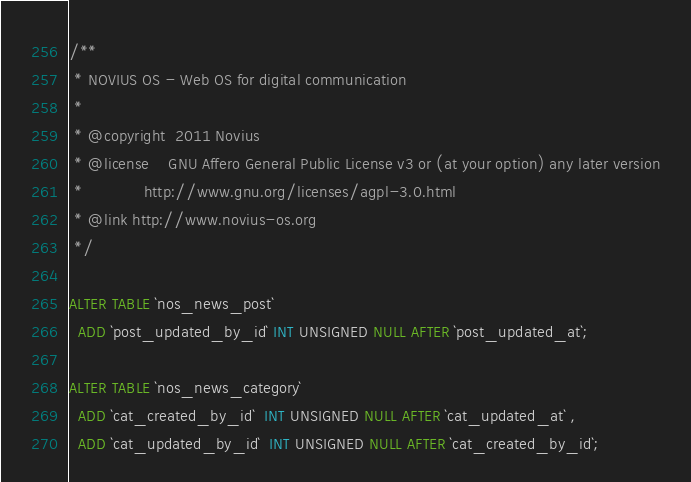Convert code to text. <code><loc_0><loc_0><loc_500><loc_500><_SQL_>/**
 * NOVIUS OS - Web OS for digital communication
 *
 * @copyright  2011 Novius
 * @license    GNU Affero General Public License v3 or (at your option) any later version
 *             http://www.gnu.org/licenses/agpl-3.0.html
 * @link http://www.novius-os.org
 */

ALTER TABLE `nos_news_post`
  ADD `post_updated_by_id` INT UNSIGNED NULL AFTER `post_updated_at`;

ALTER TABLE `nos_news_category`
  ADD `cat_created_by_id`  INT UNSIGNED NULL AFTER `cat_updated_at` ,
  ADD `cat_updated_by_id`  INT UNSIGNED NULL AFTER `cat_created_by_id`;
</code> 